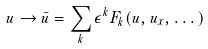<formula> <loc_0><loc_0><loc_500><loc_500>u \rightarrow \bar { u } = \sum _ { k } \epsilon ^ { k } F _ { k } ( u , u _ { x } , \dots )</formula> 